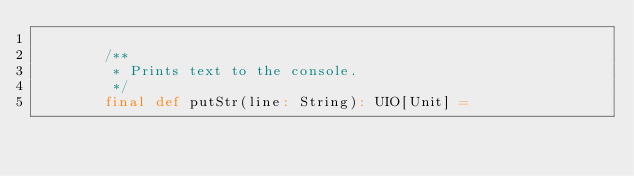Convert code to text. <code><loc_0><loc_0><loc_500><loc_500><_Scala_>
        /**
         * Prints text to the console.
         */
        final def putStr(line: String): UIO[Unit] =</code> 